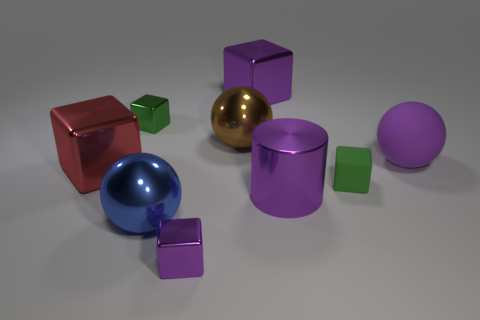There is a big blue thing; is it the same shape as the tiny green matte object that is behind the purple cylinder?
Offer a terse response. No. What color is the small block that is both left of the tiny rubber cube and in front of the big purple rubber sphere?
Provide a short and direct response. Purple. What is the cube that is left of the tiny green object that is on the left side of the metallic block that is right of the large brown object made of?
Offer a very short reply. Metal. What is the material of the large purple ball?
Give a very brief answer. Rubber. There is a blue metallic thing that is the same shape as the brown thing; what is its size?
Your answer should be compact. Large. Does the small rubber object have the same color as the big matte sphere?
Keep it short and to the point. No. How many other objects are the same material as the brown ball?
Provide a short and direct response. 6. Are there an equal number of large purple metal cubes behind the cylinder and small matte things?
Provide a short and direct response. Yes. Does the purple cube behind the green metal cube have the same size as the tiny purple cube?
Provide a succinct answer. No. How many green matte cubes are in front of the green rubber object?
Provide a short and direct response. 0. 